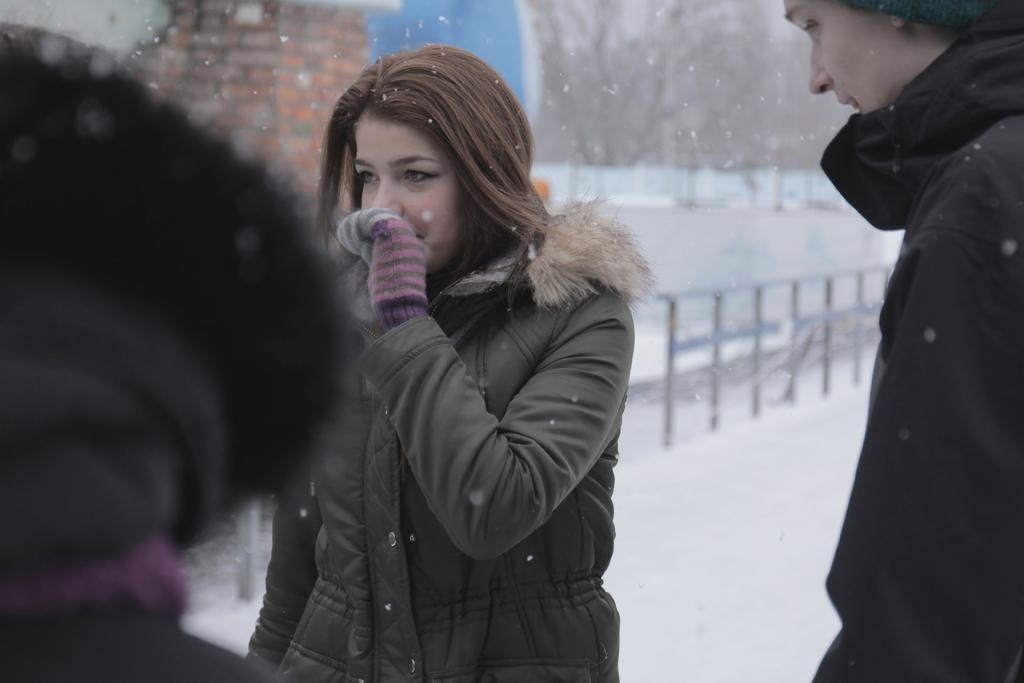Can you describe this image briefly? In this image I can see some people. In the background, I can see the snow and the rail. 